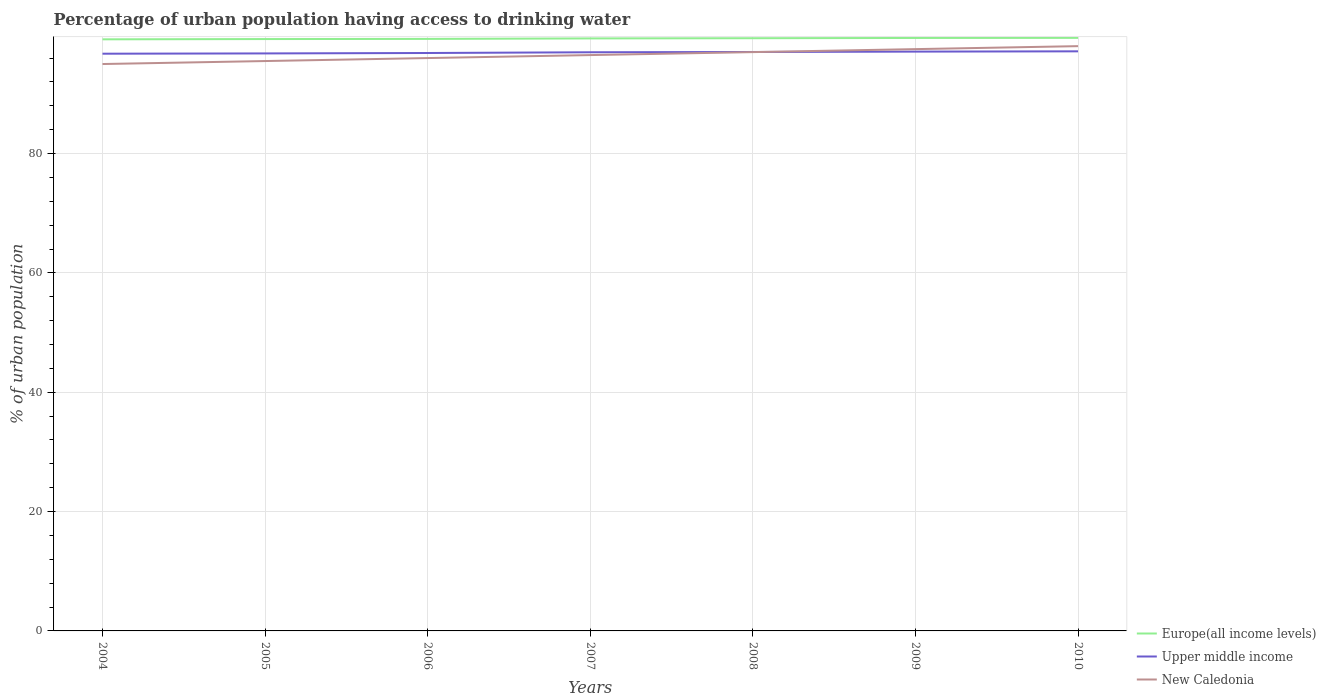How many different coloured lines are there?
Make the answer very short. 3. Does the line corresponding to Upper middle income intersect with the line corresponding to New Caledonia?
Ensure brevity in your answer.  Yes. Across all years, what is the maximum percentage of urban population having access to drinking water in Upper middle income?
Your answer should be very brief. 96.73. What is the total percentage of urban population having access to drinking water in New Caledonia in the graph?
Your answer should be very brief. -1.5. What is the difference between the highest and the lowest percentage of urban population having access to drinking water in New Caledonia?
Provide a succinct answer. 3. Is the percentage of urban population having access to drinking water in New Caledonia strictly greater than the percentage of urban population having access to drinking water in Upper middle income over the years?
Provide a short and direct response. No. How many years are there in the graph?
Provide a short and direct response. 7. What is the difference between two consecutive major ticks on the Y-axis?
Your answer should be compact. 20. Where does the legend appear in the graph?
Offer a terse response. Bottom right. How many legend labels are there?
Offer a very short reply. 3. How are the legend labels stacked?
Ensure brevity in your answer.  Vertical. What is the title of the graph?
Offer a very short reply. Percentage of urban population having access to drinking water. Does "Mauritania" appear as one of the legend labels in the graph?
Provide a succinct answer. No. What is the label or title of the X-axis?
Provide a succinct answer. Years. What is the label or title of the Y-axis?
Your answer should be compact. % of urban population. What is the % of urban population of Europe(all income levels) in 2004?
Provide a short and direct response. 99.14. What is the % of urban population of Upper middle income in 2004?
Make the answer very short. 96.73. What is the % of urban population of New Caledonia in 2004?
Give a very brief answer. 95. What is the % of urban population of Europe(all income levels) in 2005?
Provide a short and direct response. 99.19. What is the % of urban population of Upper middle income in 2005?
Give a very brief answer. 96.78. What is the % of urban population in New Caledonia in 2005?
Your response must be concise. 95.5. What is the % of urban population of Europe(all income levels) in 2006?
Provide a succinct answer. 99.21. What is the % of urban population in Upper middle income in 2006?
Ensure brevity in your answer.  96.85. What is the % of urban population of New Caledonia in 2006?
Give a very brief answer. 96. What is the % of urban population in Europe(all income levels) in 2007?
Ensure brevity in your answer.  99.29. What is the % of urban population of Upper middle income in 2007?
Your response must be concise. 96.97. What is the % of urban population of New Caledonia in 2007?
Your response must be concise. 96.5. What is the % of urban population in Europe(all income levels) in 2008?
Provide a succinct answer. 99.33. What is the % of urban population of Upper middle income in 2008?
Keep it short and to the point. 97.02. What is the % of urban population in New Caledonia in 2008?
Offer a very short reply. 97. What is the % of urban population of Europe(all income levels) in 2009?
Ensure brevity in your answer.  99.37. What is the % of urban population of Upper middle income in 2009?
Your response must be concise. 97.08. What is the % of urban population of New Caledonia in 2009?
Keep it short and to the point. 97.5. What is the % of urban population of Europe(all income levels) in 2010?
Provide a short and direct response. 99.38. What is the % of urban population in Upper middle income in 2010?
Keep it short and to the point. 97.13. Across all years, what is the maximum % of urban population in Europe(all income levels)?
Provide a short and direct response. 99.38. Across all years, what is the maximum % of urban population in Upper middle income?
Your answer should be very brief. 97.13. Across all years, what is the minimum % of urban population in Europe(all income levels)?
Offer a terse response. 99.14. Across all years, what is the minimum % of urban population of Upper middle income?
Your response must be concise. 96.73. Across all years, what is the minimum % of urban population of New Caledonia?
Make the answer very short. 95. What is the total % of urban population of Europe(all income levels) in the graph?
Offer a very short reply. 694.91. What is the total % of urban population of Upper middle income in the graph?
Provide a short and direct response. 678.57. What is the total % of urban population of New Caledonia in the graph?
Provide a succinct answer. 675.5. What is the difference between the % of urban population in Europe(all income levels) in 2004 and that in 2005?
Offer a very short reply. -0.05. What is the difference between the % of urban population of Upper middle income in 2004 and that in 2005?
Your answer should be very brief. -0.05. What is the difference between the % of urban population of Europe(all income levels) in 2004 and that in 2006?
Keep it short and to the point. -0.07. What is the difference between the % of urban population of Upper middle income in 2004 and that in 2006?
Ensure brevity in your answer.  -0.12. What is the difference between the % of urban population of New Caledonia in 2004 and that in 2006?
Provide a short and direct response. -1. What is the difference between the % of urban population in Europe(all income levels) in 2004 and that in 2007?
Your answer should be very brief. -0.15. What is the difference between the % of urban population of Upper middle income in 2004 and that in 2007?
Your answer should be compact. -0.24. What is the difference between the % of urban population of New Caledonia in 2004 and that in 2007?
Ensure brevity in your answer.  -1.5. What is the difference between the % of urban population of Europe(all income levels) in 2004 and that in 2008?
Provide a short and direct response. -0.19. What is the difference between the % of urban population of Upper middle income in 2004 and that in 2008?
Ensure brevity in your answer.  -0.29. What is the difference between the % of urban population of Europe(all income levels) in 2004 and that in 2009?
Ensure brevity in your answer.  -0.23. What is the difference between the % of urban population in Upper middle income in 2004 and that in 2009?
Make the answer very short. -0.35. What is the difference between the % of urban population in Europe(all income levels) in 2004 and that in 2010?
Your answer should be compact. -0.24. What is the difference between the % of urban population of Upper middle income in 2004 and that in 2010?
Give a very brief answer. -0.4. What is the difference between the % of urban population of New Caledonia in 2004 and that in 2010?
Offer a very short reply. -3. What is the difference between the % of urban population in Europe(all income levels) in 2005 and that in 2006?
Ensure brevity in your answer.  -0.03. What is the difference between the % of urban population of Upper middle income in 2005 and that in 2006?
Your answer should be very brief. -0.07. What is the difference between the % of urban population of Europe(all income levels) in 2005 and that in 2007?
Ensure brevity in your answer.  -0.11. What is the difference between the % of urban population of Upper middle income in 2005 and that in 2007?
Ensure brevity in your answer.  -0.19. What is the difference between the % of urban population of Europe(all income levels) in 2005 and that in 2008?
Ensure brevity in your answer.  -0.14. What is the difference between the % of urban population in Upper middle income in 2005 and that in 2008?
Offer a very short reply. -0.24. What is the difference between the % of urban population of New Caledonia in 2005 and that in 2008?
Your answer should be compact. -1.5. What is the difference between the % of urban population of Europe(all income levels) in 2005 and that in 2009?
Keep it short and to the point. -0.18. What is the difference between the % of urban population of Upper middle income in 2005 and that in 2009?
Give a very brief answer. -0.3. What is the difference between the % of urban population in New Caledonia in 2005 and that in 2009?
Offer a very short reply. -2. What is the difference between the % of urban population in Europe(all income levels) in 2005 and that in 2010?
Keep it short and to the point. -0.2. What is the difference between the % of urban population in Upper middle income in 2005 and that in 2010?
Your answer should be very brief. -0.35. What is the difference between the % of urban population of New Caledonia in 2005 and that in 2010?
Your answer should be compact. -2.5. What is the difference between the % of urban population of Europe(all income levels) in 2006 and that in 2007?
Offer a terse response. -0.08. What is the difference between the % of urban population of Upper middle income in 2006 and that in 2007?
Offer a terse response. -0.12. What is the difference between the % of urban population in Europe(all income levels) in 2006 and that in 2008?
Make the answer very short. -0.11. What is the difference between the % of urban population of Upper middle income in 2006 and that in 2008?
Give a very brief answer. -0.17. What is the difference between the % of urban population in Europe(all income levels) in 2006 and that in 2009?
Provide a short and direct response. -0.16. What is the difference between the % of urban population in Upper middle income in 2006 and that in 2009?
Keep it short and to the point. -0.23. What is the difference between the % of urban population of New Caledonia in 2006 and that in 2009?
Your answer should be compact. -1.5. What is the difference between the % of urban population in Europe(all income levels) in 2006 and that in 2010?
Give a very brief answer. -0.17. What is the difference between the % of urban population in Upper middle income in 2006 and that in 2010?
Make the answer very short. -0.28. What is the difference between the % of urban population of Europe(all income levels) in 2007 and that in 2008?
Your answer should be compact. -0.03. What is the difference between the % of urban population of Upper middle income in 2007 and that in 2008?
Make the answer very short. -0.05. What is the difference between the % of urban population in Europe(all income levels) in 2007 and that in 2009?
Give a very brief answer. -0.07. What is the difference between the % of urban population of Upper middle income in 2007 and that in 2009?
Your answer should be very brief. -0.11. What is the difference between the % of urban population in Europe(all income levels) in 2007 and that in 2010?
Your answer should be compact. -0.09. What is the difference between the % of urban population in Upper middle income in 2007 and that in 2010?
Your answer should be very brief. -0.16. What is the difference between the % of urban population of New Caledonia in 2007 and that in 2010?
Provide a short and direct response. -1.5. What is the difference between the % of urban population of Europe(all income levels) in 2008 and that in 2009?
Your answer should be compact. -0.04. What is the difference between the % of urban population of Upper middle income in 2008 and that in 2009?
Keep it short and to the point. -0.06. What is the difference between the % of urban population of New Caledonia in 2008 and that in 2009?
Keep it short and to the point. -0.5. What is the difference between the % of urban population of Europe(all income levels) in 2008 and that in 2010?
Give a very brief answer. -0.06. What is the difference between the % of urban population of Upper middle income in 2008 and that in 2010?
Offer a terse response. -0.11. What is the difference between the % of urban population in Europe(all income levels) in 2009 and that in 2010?
Make the answer very short. -0.01. What is the difference between the % of urban population of Upper middle income in 2009 and that in 2010?
Ensure brevity in your answer.  -0.05. What is the difference between the % of urban population of New Caledonia in 2009 and that in 2010?
Ensure brevity in your answer.  -0.5. What is the difference between the % of urban population in Europe(all income levels) in 2004 and the % of urban population in Upper middle income in 2005?
Ensure brevity in your answer.  2.36. What is the difference between the % of urban population of Europe(all income levels) in 2004 and the % of urban population of New Caledonia in 2005?
Provide a short and direct response. 3.64. What is the difference between the % of urban population of Upper middle income in 2004 and the % of urban population of New Caledonia in 2005?
Give a very brief answer. 1.23. What is the difference between the % of urban population of Europe(all income levels) in 2004 and the % of urban population of Upper middle income in 2006?
Offer a terse response. 2.29. What is the difference between the % of urban population in Europe(all income levels) in 2004 and the % of urban population in New Caledonia in 2006?
Give a very brief answer. 3.14. What is the difference between the % of urban population in Upper middle income in 2004 and the % of urban population in New Caledonia in 2006?
Your answer should be very brief. 0.73. What is the difference between the % of urban population in Europe(all income levels) in 2004 and the % of urban population in Upper middle income in 2007?
Your answer should be very brief. 2.17. What is the difference between the % of urban population of Europe(all income levels) in 2004 and the % of urban population of New Caledonia in 2007?
Ensure brevity in your answer.  2.64. What is the difference between the % of urban population of Upper middle income in 2004 and the % of urban population of New Caledonia in 2007?
Ensure brevity in your answer.  0.23. What is the difference between the % of urban population in Europe(all income levels) in 2004 and the % of urban population in Upper middle income in 2008?
Provide a short and direct response. 2.12. What is the difference between the % of urban population of Europe(all income levels) in 2004 and the % of urban population of New Caledonia in 2008?
Make the answer very short. 2.14. What is the difference between the % of urban population in Upper middle income in 2004 and the % of urban population in New Caledonia in 2008?
Your response must be concise. -0.27. What is the difference between the % of urban population of Europe(all income levels) in 2004 and the % of urban population of Upper middle income in 2009?
Provide a succinct answer. 2.06. What is the difference between the % of urban population in Europe(all income levels) in 2004 and the % of urban population in New Caledonia in 2009?
Give a very brief answer. 1.64. What is the difference between the % of urban population in Upper middle income in 2004 and the % of urban population in New Caledonia in 2009?
Your answer should be compact. -0.77. What is the difference between the % of urban population in Europe(all income levels) in 2004 and the % of urban population in Upper middle income in 2010?
Provide a short and direct response. 2.01. What is the difference between the % of urban population of Europe(all income levels) in 2004 and the % of urban population of New Caledonia in 2010?
Keep it short and to the point. 1.14. What is the difference between the % of urban population of Upper middle income in 2004 and the % of urban population of New Caledonia in 2010?
Offer a very short reply. -1.27. What is the difference between the % of urban population of Europe(all income levels) in 2005 and the % of urban population of Upper middle income in 2006?
Offer a terse response. 2.34. What is the difference between the % of urban population of Europe(all income levels) in 2005 and the % of urban population of New Caledonia in 2006?
Your answer should be very brief. 3.19. What is the difference between the % of urban population of Upper middle income in 2005 and the % of urban population of New Caledonia in 2006?
Give a very brief answer. 0.78. What is the difference between the % of urban population of Europe(all income levels) in 2005 and the % of urban population of Upper middle income in 2007?
Provide a short and direct response. 2.21. What is the difference between the % of urban population in Europe(all income levels) in 2005 and the % of urban population in New Caledonia in 2007?
Provide a succinct answer. 2.69. What is the difference between the % of urban population of Upper middle income in 2005 and the % of urban population of New Caledonia in 2007?
Offer a very short reply. 0.28. What is the difference between the % of urban population in Europe(all income levels) in 2005 and the % of urban population in Upper middle income in 2008?
Offer a terse response. 2.17. What is the difference between the % of urban population of Europe(all income levels) in 2005 and the % of urban population of New Caledonia in 2008?
Provide a succinct answer. 2.19. What is the difference between the % of urban population in Upper middle income in 2005 and the % of urban population in New Caledonia in 2008?
Offer a very short reply. -0.22. What is the difference between the % of urban population of Europe(all income levels) in 2005 and the % of urban population of Upper middle income in 2009?
Provide a succinct answer. 2.1. What is the difference between the % of urban population of Europe(all income levels) in 2005 and the % of urban population of New Caledonia in 2009?
Provide a short and direct response. 1.69. What is the difference between the % of urban population of Upper middle income in 2005 and the % of urban population of New Caledonia in 2009?
Keep it short and to the point. -0.72. What is the difference between the % of urban population of Europe(all income levels) in 2005 and the % of urban population of Upper middle income in 2010?
Ensure brevity in your answer.  2.06. What is the difference between the % of urban population of Europe(all income levels) in 2005 and the % of urban population of New Caledonia in 2010?
Make the answer very short. 1.19. What is the difference between the % of urban population of Upper middle income in 2005 and the % of urban population of New Caledonia in 2010?
Ensure brevity in your answer.  -1.22. What is the difference between the % of urban population in Europe(all income levels) in 2006 and the % of urban population in Upper middle income in 2007?
Make the answer very short. 2.24. What is the difference between the % of urban population in Europe(all income levels) in 2006 and the % of urban population in New Caledonia in 2007?
Provide a short and direct response. 2.71. What is the difference between the % of urban population of Upper middle income in 2006 and the % of urban population of New Caledonia in 2007?
Your response must be concise. 0.35. What is the difference between the % of urban population in Europe(all income levels) in 2006 and the % of urban population in Upper middle income in 2008?
Keep it short and to the point. 2.19. What is the difference between the % of urban population of Europe(all income levels) in 2006 and the % of urban population of New Caledonia in 2008?
Keep it short and to the point. 2.21. What is the difference between the % of urban population of Upper middle income in 2006 and the % of urban population of New Caledonia in 2008?
Provide a short and direct response. -0.15. What is the difference between the % of urban population of Europe(all income levels) in 2006 and the % of urban population of Upper middle income in 2009?
Keep it short and to the point. 2.13. What is the difference between the % of urban population in Europe(all income levels) in 2006 and the % of urban population in New Caledonia in 2009?
Your response must be concise. 1.71. What is the difference between the % of urban population of Upper middle income in 2006 and the % of urban population of New Caledonia in 2009?
Offer a terse response. -0.65. What is the difference between the % of urban population in Europe(all income levels) in 2006 and the % of urban population in Upper middle income in 2010?
Offer a very short reply. 2.08. What is the difference between the % of urban population of Europe(all income levels) in 2006 and the % of urban population of New Caledonia in 2010?
Ensure brevity in your answer.  1.21. What is the difference between the % of urban population of Upper middle income in 2006 and the % of urban population of New Caledonia in 2010?
Offer a terse response. -1.15. What is the difference between the % of urban population in Europe(all income levels) in 2007 and the % of urban population in Upper middle income in 2008?
Offer a terse response. 2.27. What is the difference between the % of urban population in Europe(all income levels) in 2007 and the % of urban population in New Caledonia in 2008?
Provide a succinct answer. 2.29. What is the difference between the % of urban population of Upper middle income in 2007 and the % of urban population of New Caledonia in 2008?
Keep it short and to the point. -0.03. What is the difference between the % of urban population of Europe(all income levels) in 2007 and the % of urban population of Upper middle income in 2009?
Provide a short and direct response. 2.21. What is the difference between the % of urban population in Europe(all income levels) in 2007 and the % of urban population in New Caledonia in 2009?
Offer a very short reply. 1.79. What is the difference between the % of urban population of Upper middle income in 2007 and the % of urban population of New Caledonia in 2009?
Your response must be concise. -0.53. What is the difference between the % of urban population of Europe(all income levels) in 2007 and the % of urban population of Upper middle income in 2010?
Make the answer very short. 2.16. What is the difference between the % of urban population of Europe(all income levels) in 2007 and the % of urban population of New Caledonia in 2010?
Provide a short and direct response. 1.29. What is the difference between the % of urban population in Upper middle income in 2007 and the % of urban population in New Caledonia in 2010?
Ensure brevity in your answer.  -1.03. What is the difference between the % of urban population of Europe(all income levels) in 2008 and the % of urban population of Upper middle income in 2009?
Give a very brief answer. 2.24. What is the difference between the % of urban population in Europe(all income levels) in 2008 and the % of urban population in New Caledonia in 2009?
Provide a succinct answer. 1.83. What is the difference between the % of urban population of Upper middle income in 2008 and the % of urban population of New Caledonia in 2009?
Give a very brief answer. -0.48. What is the difference between the % of urban population in Europe(all income levels) in 2008 and the % of urban population in Upper middle income in 2010?
Offer a terse response. 2.2. What is the difference between the % of urban population of Europe(all income levels) in 2008 and the % of urban population of New Caledonia in 2010?
Make the answer very short. 1.33. What is the difference between the % of urban population of Upper middle income in 2008 and the % of urban population of New Caledonia in 2010?
Your response must be concise. -0.98. What is the difference between the % of urban population of Europe(all income levels) in 2009 and the % of urban population of Upper middle income in 2010?
Keep it short and to the point. 2.24. What is the difference between the % of urban population of Europe(all income levels) in 2009 and the % of urban population of New Caledonia in 2010?
Your answer should be compact. 1.37. What is the difference between the % of urban population of Upper middle income in 2009 and the % of urban population of New Caledonia in 2010?
Give a very brief answer. -0.92. What is the average % of urban population in Europe(all income levels) per year?
Your answer should be very brief. 99.27. What is the average % of urban population in Upper middle income per year?
Ensure brevity in your answer.  96.94. What is the average % of urban population in New Caledonia per year?
Your answer should be compact. 96.5. In the year 2004, what is the difference between the % of urban population in Europe(all income levels) and % of urban population in Upper middle income?
Ensure brevity in your answer.  2.41. In the year 2004, what is the difference between the % of urban population in Europe(all income levels) and % of urban population in New Caledonia?
Make the answer very short. 4.14. In the year 2004, what is the difference between the % of urban population of Upper middle income and % of urban population of New Caledonia?
Ensure brevity in your answer.  1.73. In the year 2005, what is the difference between the % of urban population in Europe(all income levels) and % of urban population in Upper middle income?
Give a very brief answer. 2.41. In the year 2005, what is the difference between the % of urban population in Europe(all income levels) and % of urban population in New Caledonia?
Your response must be concise. 3.69. In the year 2005, what is the difference between the % of urban population in Upper middle income and % of urban population in New Caledonia?
Keep it short and to the point. 1.28. In the year 2006, what is the difference between the % of urban population of Europe(all income levels) and % of urban population of Upper middle income?
Offer a very short reply. 2.36. In the year 2006, what is the difference between the % of urban population in Europe(all income levels) and % of urban population in New Caledonia?
Offer a very short reply. 3.21. In the year 2006, what is the difference between the % of urban population in Upper middle income and % of urban population in New Caledonia?
Your response must be concise. 0.85. In the year 2007, what is the difference between the % of urban population in Europe(all income levels) and % of urban population in Upper middle income?
Ensure brevity in your answer.  2.32. In the year 2007, what is the difference between the % of urban population in Europe(all income levels) and % of urban population in New Caledonia?
Provide a short and direct response. 2.79. In the year 2007, what is the difference between the % of urban population in Upper middle income and % of urban population in New Caledonia?
Your answer should be compact. 0.47. In the year 2008, what is the difference between the % of urban population of Europe(all income levels) and % of urban population of Upper middle income?
Your response must be concise. 2.31. In the year 2008, what is the difference between the % of urban population in Europe(all income levels) and % of urban population in New Caledonia?
Your answer should be compact. 2.33. In the year 2008, what is the difference between the % of urban population in Upper middle income and % of urban population in New Caledonia?
Give a very brief answer. 0.02. In the year 2009, what is the difference between the % of urban population of Europe(all income levels) and % of urban population of Upper middle income?
Give a very brief answer. 2.29. In the year 2009, what is the difference between the % of urban population in Europe(all income levels) and % of urban population in New Caledonia?
Your answer should be compact. 1.87. In the year 2009, what is the difference between the % of urban population in Upper middle income and % of urban population in New Caledonia?
Provide a succinct answer. -0.42. In the year 2010, what is the difference between the % of urban population in Europe(all income levels) and % of urban population in Upper middle income?
Provide a short and direct response. 2.25. In the year 2010, what is the difference between the % of urban population of Europe(all income levels) and % of urban population of New Caledonia?
Your answer should be compact. 1.38. In the year 2010, what is the difference between the % of urban population of Upper middle income and % of urban population of New Caledonia?
Make the answer very short. -0.87. What is the ratio of the % of urban population of Europe(all income levels) in 2004 to that in 2005?
Ensure brevity in your answer.  1. What is the ratio of the % of urban population in Upper middle income in 2004 to that in 2005?
Provide a short and direct response. 1. What is the ratio of the % of urban population in New Caledonia in 2004 to that in 2005?
Keep it short and to the point. 0.99. What is the ratio of the % of urban population of Europe(all income levels) in 2004 to that in 2006?
Keep it short and to the point. 1. What is the ratio of the % of urban population of New Caledonia in 2004 to that in 2006?
Your response must be concise. 0.99. What is the ratio of the % of urban population in Upper middle income in 2004 to that in 2007?
Your answer should be very brief. 1. What is the ratio of the % of urban population in New Caledonia in 2004 to that in 2007?
Offer a terse response. 0.98. What is the ratio of the % of urban population in New Caledonia in 2004 to that in 2008?
Keep it short and to the point. 0.98. What is the ratio of the % of urban population of Upper middle income in 2004 to that in 2009?
Offer a very short reply. 1. What is the ratio of the % of urban population of New Caledonia in 2004 to that in 2009?
Your answer should be compact. 0.97. What is the ratio of the % of urban population of Europe(all income levels) in 2004 to that in 2010?
Make the answer very short. 1. What is the ratio of the % of urban population of Upper middle income in 2004 to that in 2010?
Provide a short and direct response. 1. What is the ratio of the % of urban population of New Caledonia in 2004 to that in 2010?
Make the answer very short. 0.97. What is the ratio of the % of urban population of Upper middle income in 2005 to that in 2006?
Your answer should be compact. 1. What is the ratio of the % of urban population in New Caledonia in 2005 to that in 2006?
Ensure brevity in your answer.  0.99. What is the ratio of the % of urban population of Europe(all income levels) in 2005 to that in 2007?
Make the answer very short. 1. What is the ratio of the % of urban population of Upper middle income in 2005 to that in 2007?
Ensure brevity in your answer.  1. What is the ratio of the % of urban population in New Caledonia in 2005 to that in 2008?
Offer a very short reply. 0.98. What is the ratio of the % of urban population in New Caledonia in 2005 to that in 2009?
Make the answer very short. 0.98. What is the ratio of the % of urban population of Europe(all income levels) in 2005 to that in 2010?
Offer a terse response. 1. What is the ratio of the % of urban population in Upper middle income in 2005 to that in 2010?
Provide a short and direct response. 1. What is the ratio of the % of urban population in New Caledonia in 2005 to that in 2010?
Provide a succinct answer. 0.97. What is the ratio of the % of urban population in Europe(all income levels) in 2006 to that in 2007?
Your response must be concise. 1. What is the ratio of the % of urban population in Europe(all income levels) in 2006 to that in 2008?
Your response must be concise. 1. What is the ratio of the % of urban population in Upper middle income in 2006 to that in 2008?
Your response must be concise. 1. What is the ratio of the % of urban population of New Caledonia in 2006 to that in 2008?
Keep it short and to the point. 0.99. What is the ratio of the % of urban population of Upper middle income in 2006 to that in 2009?
Provide a short and direct response. 1. What is the ratio of the % of urban population in New Caledonia in 2006 to that in 2009?
Give a very brief answer. 0.98. What is the ratio of the % of urban population in New Caledonia in 2006 to that in 2010?
Ensure brevity in your answer.  0.98. What is the ratio of the % of urban population of Europe(all income levels) in 2007 to that in 2008?
Your response must be concise. 1. What is the ratio of the % of urban population of Upper middle income in 2007 to that in 2008?
Offer a very short reply. 1. What is the ratio of the % of urban population of New Caledonia in 2007 to that in 2008?
Provide a short and direct response. 0.99. What is the ratio of the % of urban population in Europe(all income levels) in 2007 to that in 2009?
Your answer should be very brief. 1. What is the ratio of the % of urban population in New Caledonia in 2007 to that in 2009?
Provide a succinct answer. 0.99. What is the ratio of the % of urban population of Upper middle income in 2007 to that in 2010?
Your answer should be compact. 1. What is the ratio of the % of urban population in New Caledonia in 2007 to that in 2010?
Offer a terse response. 0.98. What is the ratio of the % of urban population of Upper middle income in 2008 to that in 2009?
Provide a short and direct response. 1. What is the ratio of the % of urban population in New Caledonia in 2008 to that in 2009?
Provide a succinct answer. 0.99. What is the ratio of the % of urban population in Upper middle income in 2008 to that in 2010?
Your answer should be very brief. 1. What is the ratio of the % of urban population in New Caledonia in 2008 to that in 2010?
Your answer should be compact. 0.99. What is the ratio of the % of urban population of Europe(all income levels) in 2009 to that in 2010?
Keep it short and to the point. 1. What is the ratio of the % of urban population of New Caledonia in 2009 to that in 2010?
Keep it short and to the point. 0.99. What is the difference between the highest and the second highest % of urban population in Europe(all income levels)?
Your answer should be compact. 0.01. What is the difference between the highest and the second highest % of urban population of Upper middle income?
Provide a succinct answer. 0.05. What is the difference between the highest and the lowest % of urban population in Europe(all income levels)?
Your answer should be compact. 0.24. What is the difference between the highest and the lowest % of urban population in Upper middle income?
Your response must be concise. 0.4. What is the difference between the highest and the lowest % of urban population in New Caledonia?
Offer a terse response. 3. 